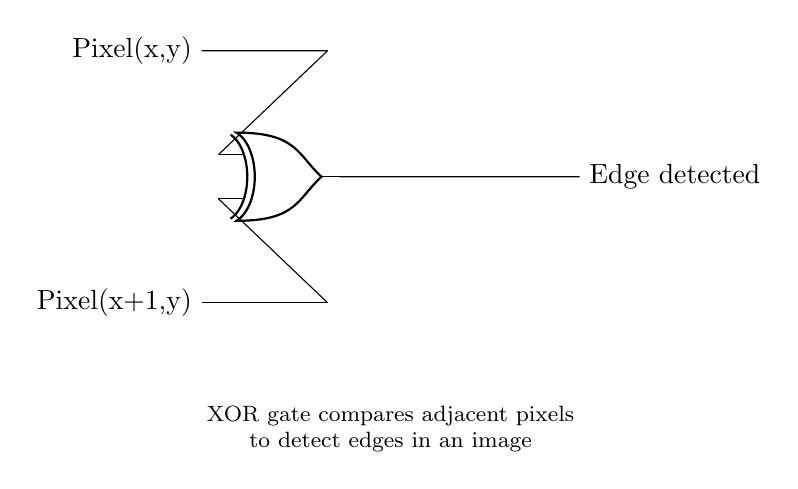What type of logic gate is used in this circuit? The circuit features an XOR gate, indicated by the symbol that has two input lines and one output line, designed for edge detection in images.
Answer: XOR gate What are the two input signals to the XOR gate? The input signals depicted are Pixel(x,y) and Pixel(x+1,y), which are adjacent pixels in the image being processed for edge detection.
Answer: Pixel(x,y) and Pixel(x+1,y) What does the output represent? The output is labeled 'Edge detected', which signifies that the XOR gate is comparing the two pixel inputs to identify edges in the image.
Answer: Edge detected How many input lines does the XOR gate have in this circuit? The XOR gate has two input lines, as shown in the diagram, where each input connects to one of the adjacent pixel values.
Answer: Two Why is an XOR gate suitable for edge detection? An XOR gate outputs a high signal (or true) when the inputs differ, meaning it can effectively highlight differences in pixel values, indicative of edges in images.
Answer: It highlights differences What is the role of the explanatory text in the circuit diagram? The explanatory text underneath the circuit provides context about the purpose of the XOR gate, detailing how it functions in relation to the input pixels for image processing.
Answer: To explain the function 